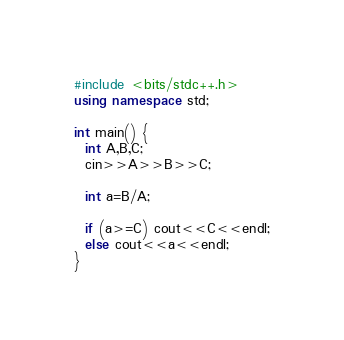Convert code to text. <code><loc_0><loc_0><loc_500><loc_500><_C++_>#include <bits/stdc++.h>
using namespace std;

int main() {
  int A,B,C;
  cin>>A>>B>>C;
  
  int a=B/A;
  
  if (a>=C) cout<<C<<endl;
  else cout<<a<<endl;
}
</code> 